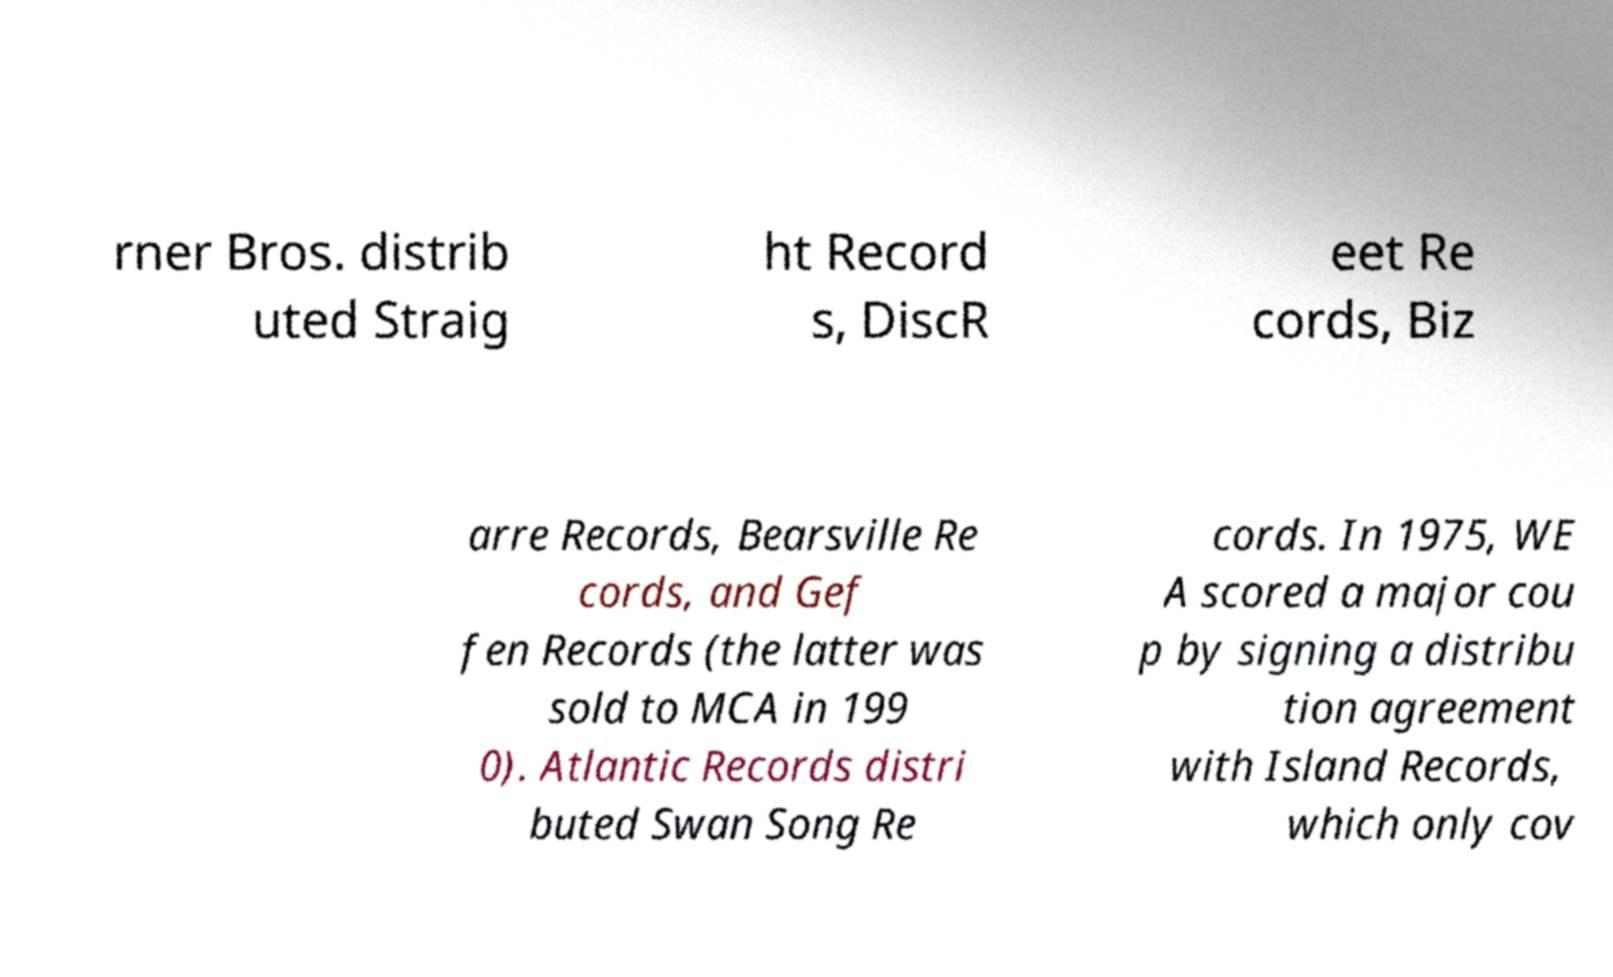Can you accurately transcribe the text from the provided image for me? rner Bros. distrib uted Straig ht Record s, DiscR eet Re cords, Biz arre Records, Bearsville Re cords, and Gef fen Records (the latter was sold to MCA in 199 0). Atlantic Records distri buted Swan Song Re cords. In 1975, WE A scored a major cou p by signing a distribu tion agreement with Island Records, which only cov 